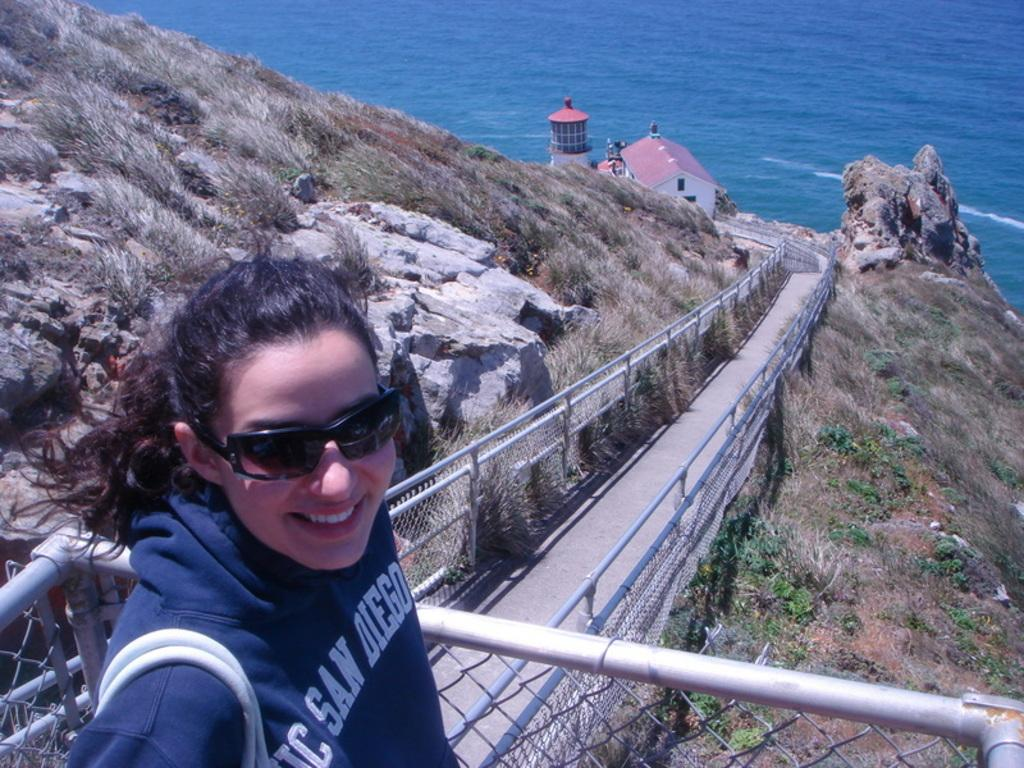Who is present in the image? There is a woman in the image. What is the woman wearing? The woman is wearing clothes and goggles. What is the woman's facial expression? The woman is smiling. What can be seen in the background of the image? There is a mesh, a path, grass, hills, a lighthouse, and sea visible in the image. What type of poison is the woman holding in the image? There is no poison present in the image; the woman is wearing goggles and smiling. What is the woman doing in the image to add more elements to the scene? The woman is not adding any elements to the scene in the image; she is simply present and smiling. 